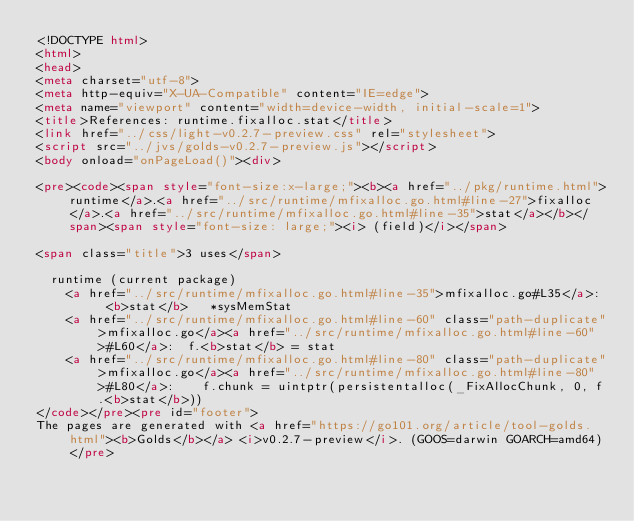Convert code to text. <code><loc_0><loc_0><loc_500><loc_500><_HTML_><!DOCTYPE html>
<html>
<head>
<meta charset="utf-8">
<meta http-equiv="X-UA-Compatible" content="IE=edge">
<meta name="viewport" content="width=device-width, initial-scale=1">
<title>References: runtime.fixalloc.stat</title>
<link href="../css/light-v0.2.7-preview.css" rel="stylesheet">
<script src="../jvs/golds-v0.2.7-preview.js"></script>
<body onload="onPageLoad()"><div>

<pre><code><span style="font-size:x-large;"><b><a href="../pkg/runtime.html">runtime</a>.<a href="../src/runtime/mfixalloc.go.html#line-27">fixalloc</a>.<a href="../src/runtime/mfixalloc.go.html#line-35">stat</a></b></span><span style="font-size: large;"><i> (field)</i></span>

<span class="title">3 uses</span>

	runtime (current package)
		<a href="../src/runtime/mfixalloc.go.html#line-35">mfixalloc.go#L35</a>: 	<b>stat</b>   *sysMemStat
		<a href="../src/runtime/mfixalloc.go.html#line-60" class="path-duplicate">mfixalloc.go</a><a href="../src/runtime/mfixalloc.go.html#line-60">#L60</a>: 	f.<b>stat</b> = stat
		<a href="../src/runtime/mfixalloc.go.html#line-80" class="path-duplicate">mfixalloc.go</a><a href="../src/runtime/mfixalloc.go.html#line-80">#L80</a>: 		f.chunk = uintptr(persistentalloc(_FixAllocChunk, 0, f.<b>stat</b>))
</code></pre><pre id="footer">
The pages are generated with <a href="https://go101.org/article/tool-golds.html"><b>Golds</b></a> <i>v0.2.7-preview</i>. (GOOS=darwin GOARCH=amd64)</pre></code> 